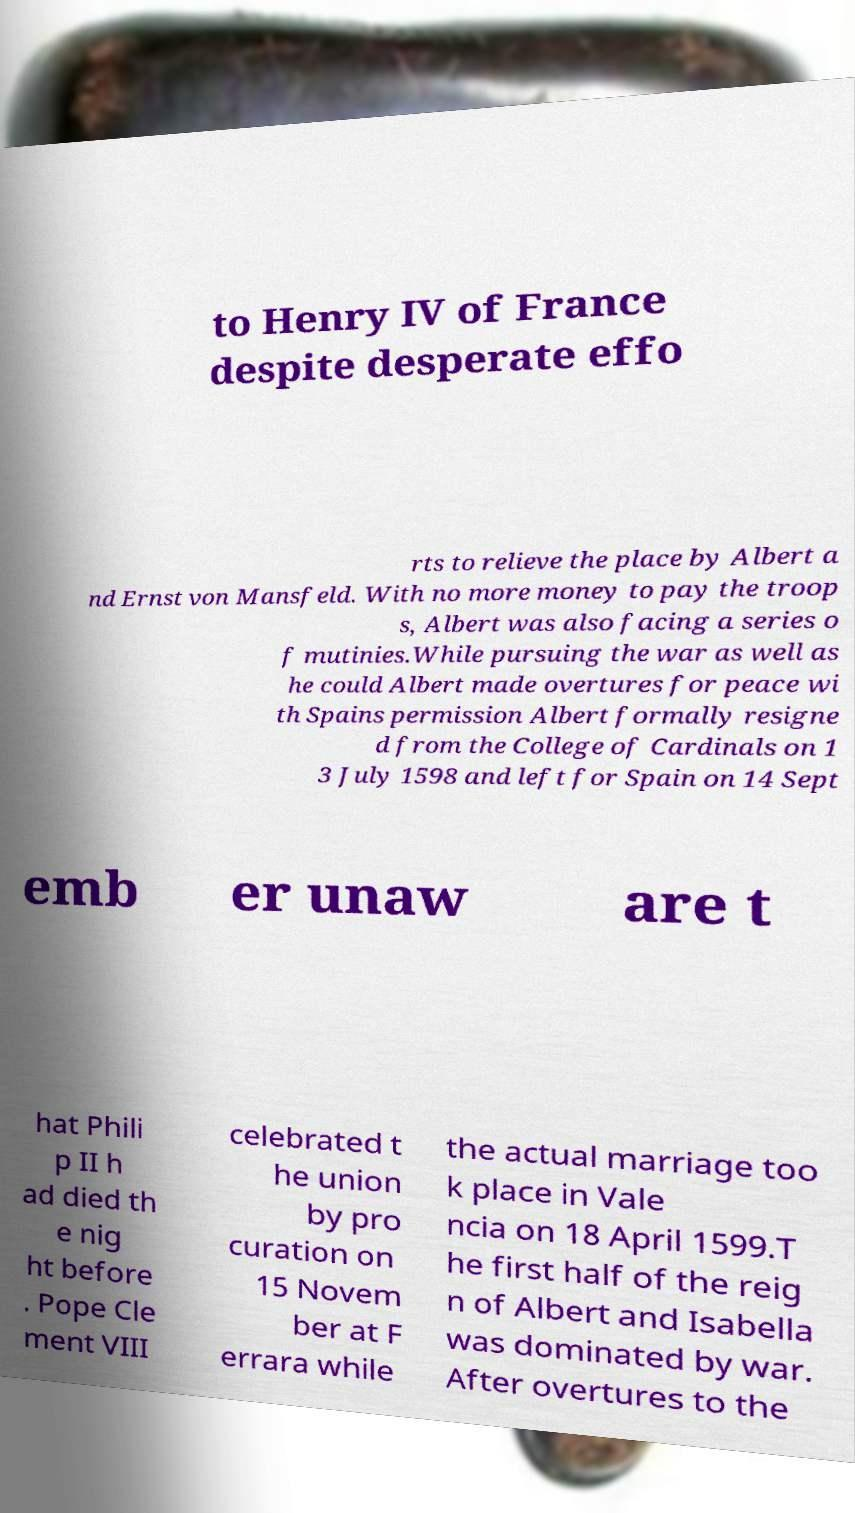For documentation purposes, I need the text within this image transcribed. Could you provide that? to Henry IV of France despite desperate effo rts to relieve the place by Albert a nd Ernst von Mansfeld. With no more money to pay the troop s, Albert was also facing a series o f mutinies.While pursuing the war as well as he could Albert made overtures for peace wi th Spains permission Albert formally resigne d from the College of Cardinals on 1 3 July 1598 and left for Spain on 14 Sept emb er unaw are t hat Phili p II h ad died th e nig ht before . Pope Cle ment VIII celebrated t he union by pro curation on 15 Novem ber at F errara while the actual marriage too k place in Vale ncia on 18 April 1599.T he first half of the reig n of Albert and Isabella was dominated by war. After overtures to the 